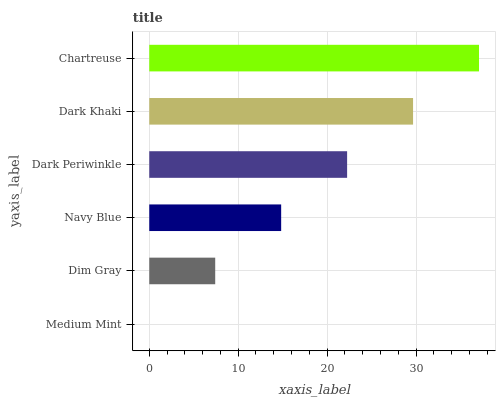Is Medium Mint the minimum?
Answer yes or no. Yes. Is Chartreuse the maximum?
Answer yes or no. Yes. Is Dim Gray the minimum?
Answer yes or no. No. Is Dim Gray the maximum?
Answer yes or no. No. Is Dim Gray greater than Medium Mint?
Answer yes or no. Yes. Is Medium Mint less than Dim Gray?
Answer yes or no. Yes. Is Medium Mint greater than Dim Gray?
Answer yes or no. No. Is Dim Gray less than Medium Mint?
Answer yes or no. No. Is Dark Periwinkle the high median?
Answer yes or no. Yes. Is Navy Blue the low median?
Answer yes or no. Yes. Is Medium Mint the high median?
Answer yes or no. No. Is Dark Khaki the low median?
Answer yes or no. No. 